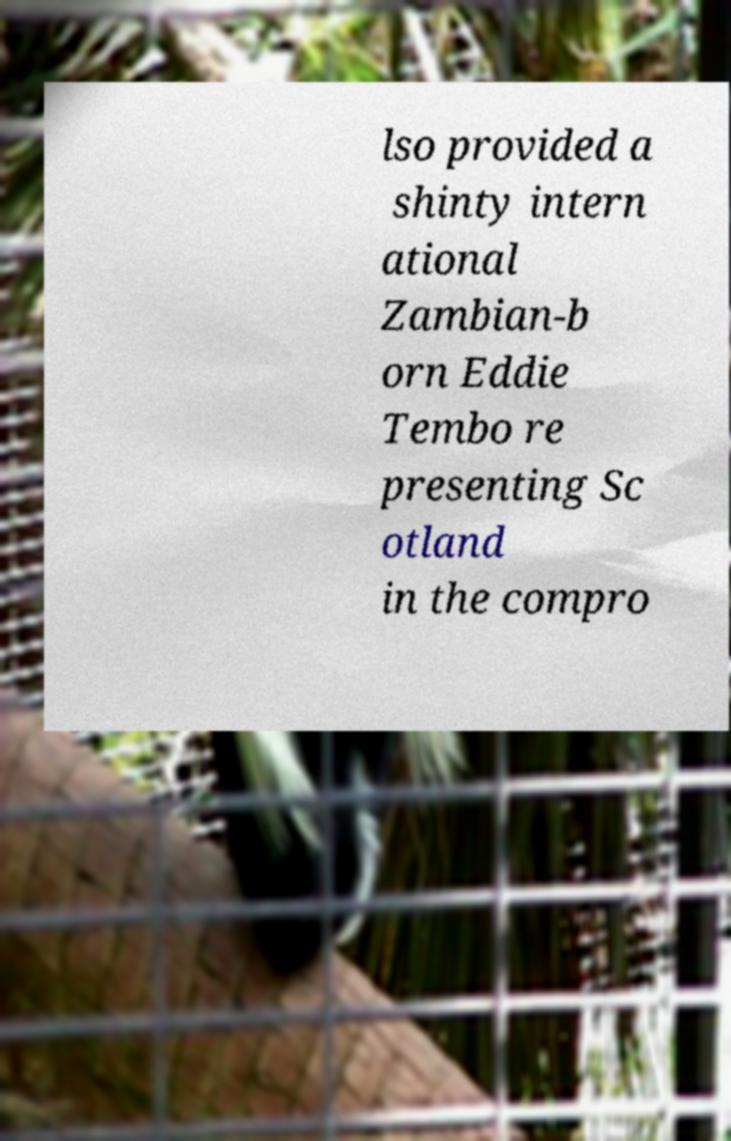There's text embedded in this image that I need extracted. Can you transcribe it verbatim? lso provided a shinty intern ational Zambian-b orn Eddie Tembo re presenting Sc otland in the compro 